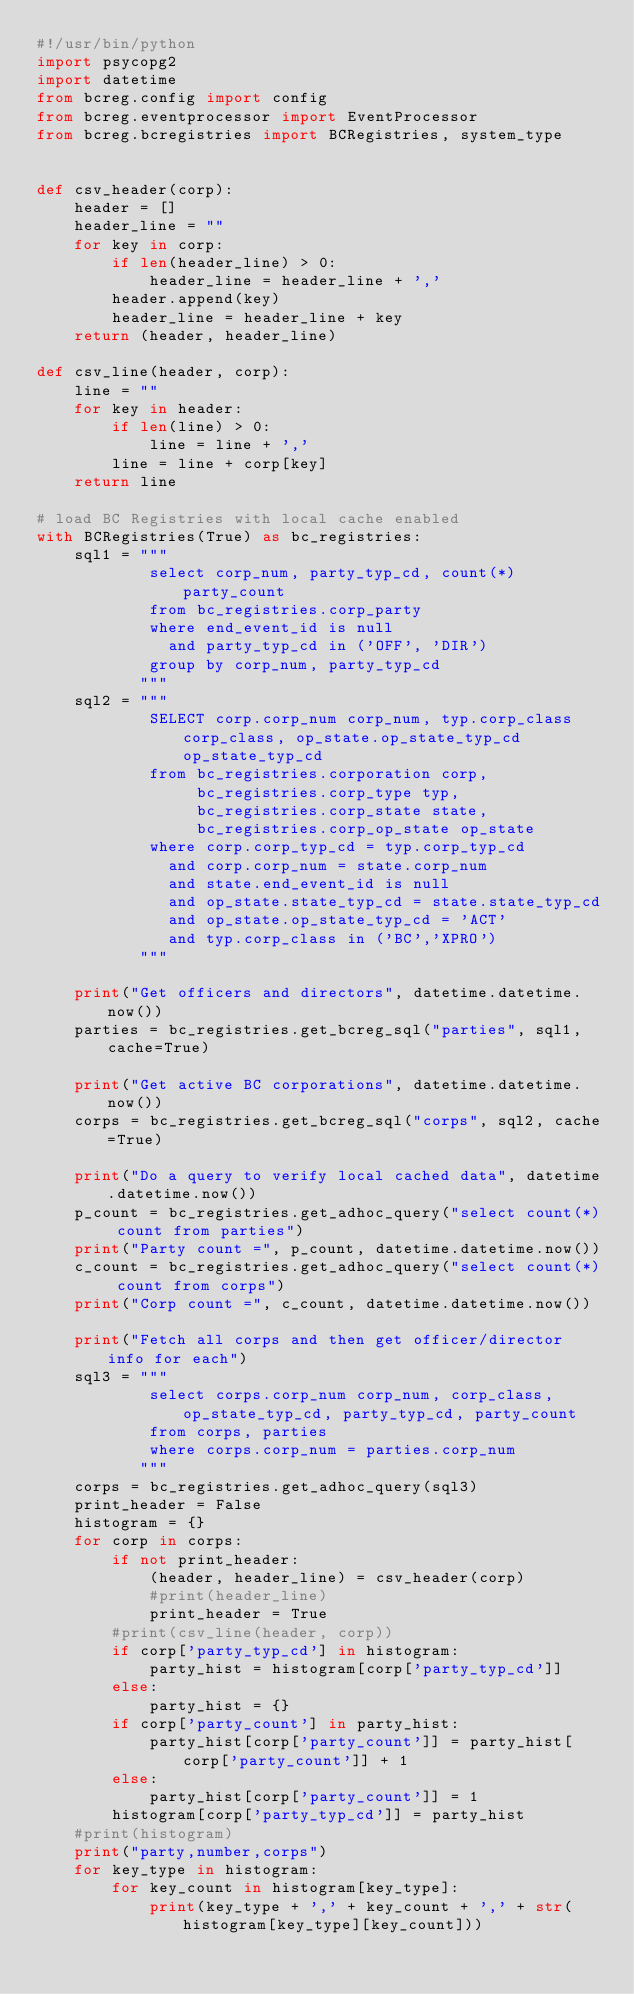<code> <loc_0><loc_0><loc_500><loc_500><_Python_>#!/usr/bin/python
import psycopg2
import datetime
from bcreg.config import config
from bcreg.eventprocessor import EventProcessor
from bcreg.bcregistries import BCRegistries, system_type


def csv_header(corp):
    header = []
    header_line = ""
    for key in corp:
        if len(header_line) > 0:
            header_line = header_line + ','
        header.append(key)
        header_line = header_line + key
    return (header, header_line)

def csv_line(header, corp):
    line = ""
    for key in header:
        if len(line) > 0:
            line = line + ','
        line = line + corp[key]
    return line

# load BC Registries with local cache enabled
with BCRegistries(True) as bc_registries:
    sql1 = """
            select corp_num, party_typ_cd, count(*) party_count
            from bc_registries.corp_party
            where end_event_id is null
              and party_typ_cd in ('OFF', 'DIR')
            group by corp_num, party_typ_cd
           """
    sql2 = """
            SELECT corp.corp_num corp_num, typ.corp_class corp_class, op_state.op_state_typ_cd op_state_typ_cd
            from bc_registries.corporation corp, 
                 bc_registries.corp_type typ,
                 bc_registries.corp_state state,
                 bc_registries.corp_op_state op_state
            where corp.corp_typ_cd = typ.corp_typ_cd 
              and corp.corp_num = state.corp_num
              and state.end_event_id is null
              and op_state.state_typ_cd = state.state_typ_cd
              and op_state.op_state_typ_cd = 'ACT'
              and typ.corp_class in ('BC','XPRO')
           """

    print("Get officers and directors", datetime.datetime.now())
    parties = bc_registries.get_bcreg_sql("parties", sql1, cache=True)

    print("Get active BC corporations", datetime.datetime.now())
    corps = bc_registries.get_bcreg_sql("corps", sql2, cache=True)

    print("Do a query to verify local cached data", datetime.datetime.now())
    p_count = bc_registries.get_adhoc_query("select count(*) count from parties")
    print("Party count =", p_count, datetime.datetime.now())
    c_count = bc_registries.get_adhoc_query("select count(*) count from corps")
    print("Corp count =", c_count, datetime.datetime.now())

    print("Fetch all corps and then get officer/director info for each")
    sql3 = """
            select corps.corp_num corp_num, corp_class, op_state_typ_cd, party_typ_cd, party_count
            from corps, parties
            where corps.corp_num = parties.corp_num
           """
    corps = bc_registries.get_adhoc_query(sql3)
    print_header = False
    histogram = {}
    for corp in corps:
        if not print_header:
            (header, header_line) = csv_header(corp)
            #print(header_line)
            print_header = True
        #print(csv_line(header, corp))
        if corp['party_typ_cd'] in histogram:
            party_hist = histogram[corp['party_typ_cd']]
        else:
            party_hist = {}
        if corp['party_count'] in party_hist:
            party_hist[corp['party_count']] = party_hist[corp['party_count']] + 1
        else:
            party_hist[corp['party_count']] = 1
        histogram[corp['party_typ_cd']] = party_hist
    #print(histogram)
    print("party,number,corps")
    for key_type in histogram:
        for key_count in histogram[key_type]:
            print(key_type + ',' + key_count + ',' + str(histogram[key_type][key_count]))

</code> 